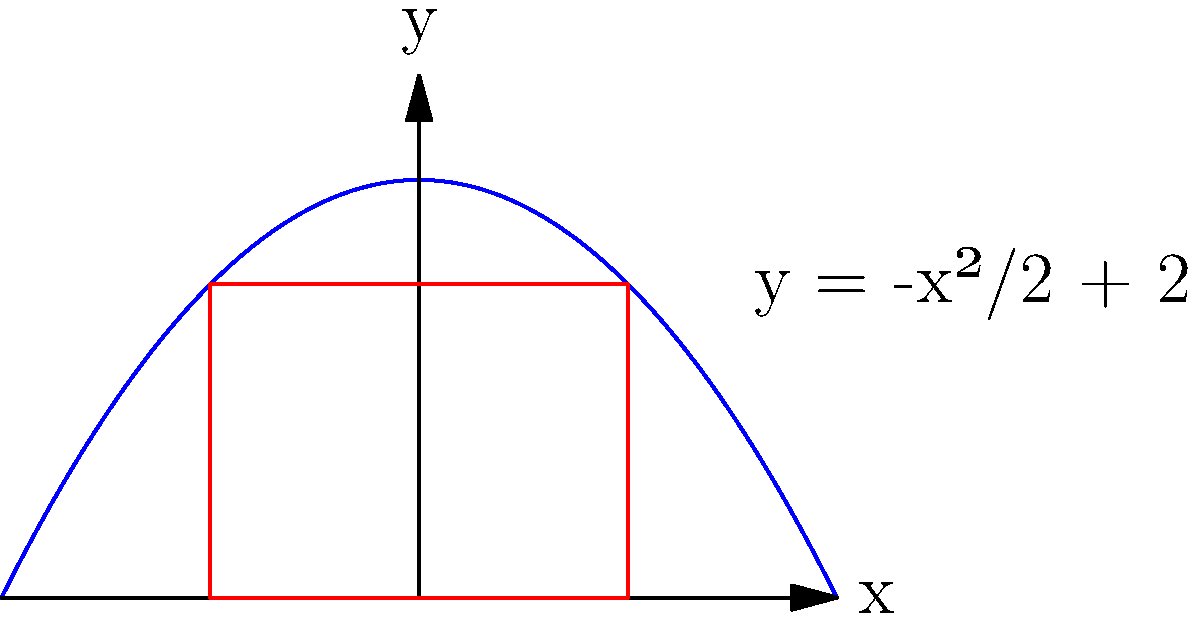A parabola is given by the equation $y = -\frac{x^2}{2} + 2$. Find the maximum area of a rectangle that can be inscribed in this parabola with its base on the x-axis. Let's approach this step-by-step:

1) Let the width of the rectangle be $2x$. The height will be $y = -\frac{x^2}{2} + 2$.

2) The area of the rectangle is:
   $A = 2x \cdot y = 2x(-\frac{x^2}{2} + 2) = -x^3 + 4x$

3) To find the maximum area, we need to differentiate $A$ with respect to $x$ and set it to zero:
   $\frac{dA}{dx} = -3x^2 + 4 = 0$

4) Solving this equation:
   $-3x^2 + 4 = 0$
   $3x^2 = 4$
   $x^2 = \frac{4}{3}$
   $x = \pm \sqrt{\frac{4}{3}} = \pm \frac{2}{\sqrt{3}}$

5) Since we're dealing with width, we'll use the positive value: $x = \frac{2}{\sqrt{3}}$

6) The width of the rectangle is $2x = \frac{4}{\sqrt{3}}$

7) The height of the rectangle is:
   $y = -\frac{x^2}{2} + 2 = -\frac{(\frac{2}{\sqrt{3}})^2}{2} + 2 = -\frac{4}{6} + 2 = \frac{4}{3}$

8) Therefore, the maximum area is:
   $A_{max} = \frac{4}{\sqrt{3}} \cdot \frac{4}{3} = \frac{16}{3\sqrt{3}}$
Answer: $\frac{16}{3\sqrt{3}}$ 